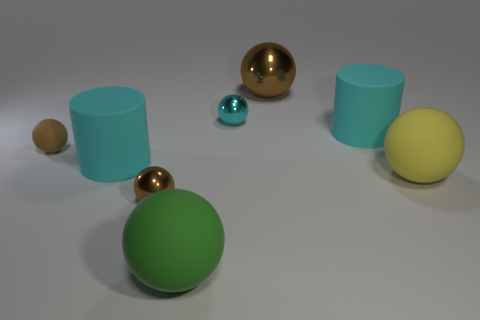Subtract all big metallic balls. How many balls are left? 5 Subtract all cylinders. How many objects are left? 6 Add 2 large green cylinders. How many objects exist? 10 Subtract all brown spheres. How many spheres are left? 3 Subtract 2 cylinders. How many cylinders are left? 0 Subtract all gray spheres. Subtract all cyan cubes. How many spheres are left? 6 Subtract all brown cubes. How many green cylinders are left? 0 Subtract all big gray matte things. Subtract all green matte objects. How many objects are left? 7 Add 5 brown shiny balls. How many brown shiny balls are left? 7 Add 5 small things. How many small things exist? 8 